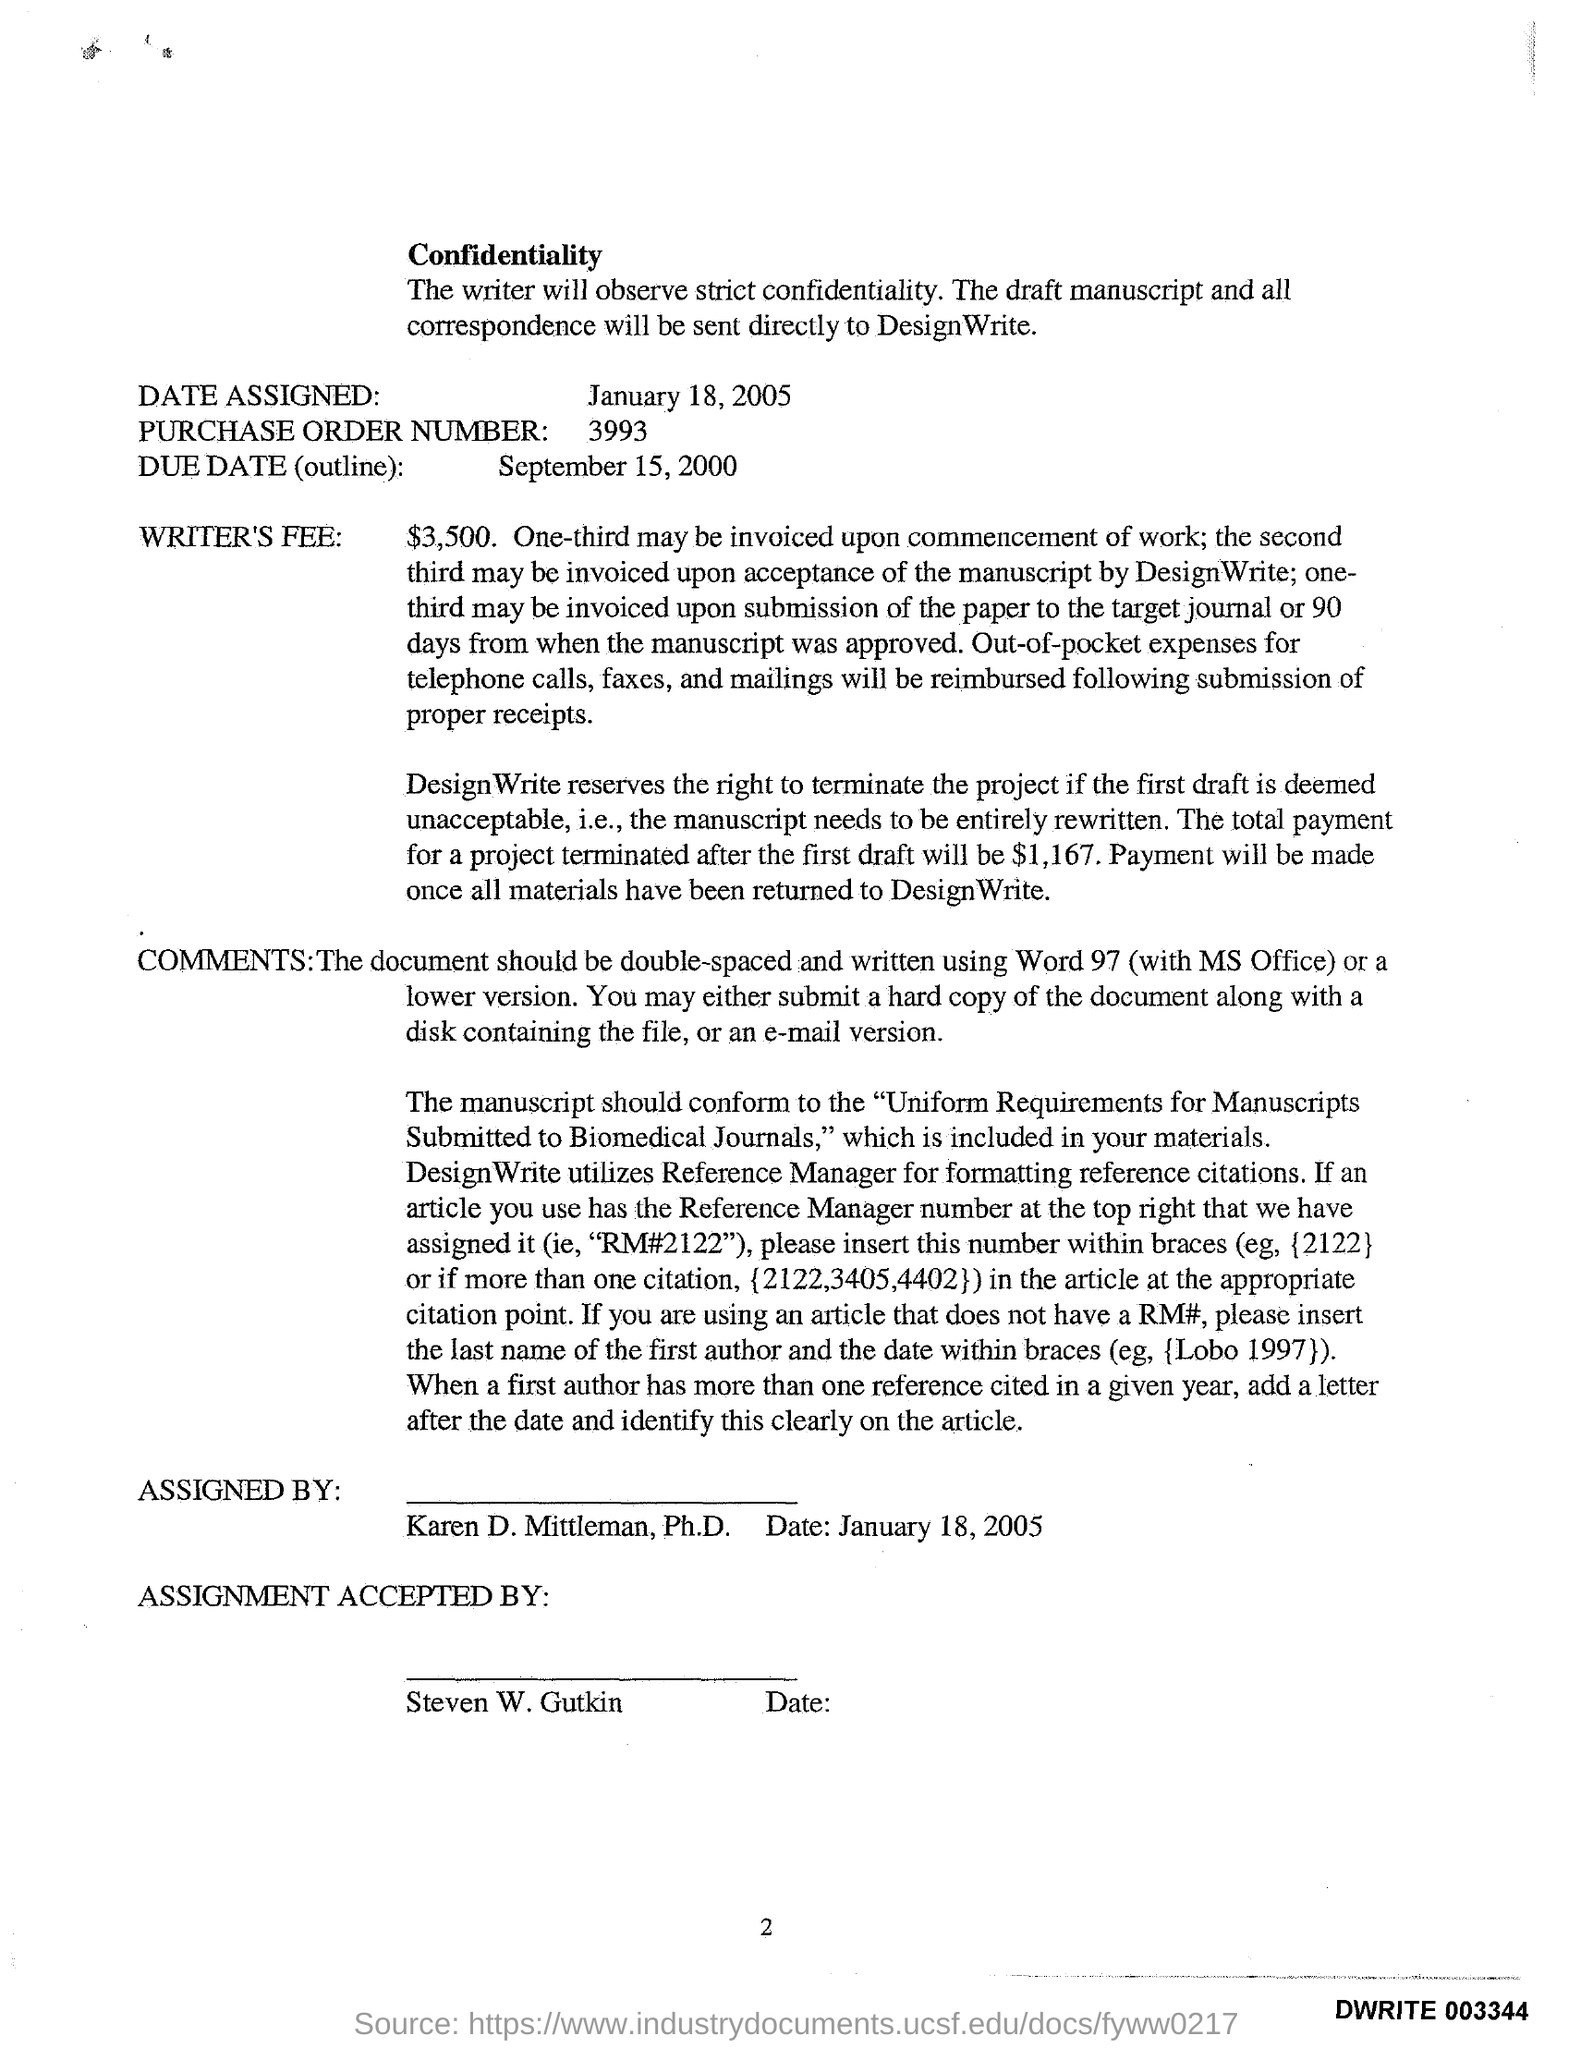What is the date assigned?
Provide a short and direct response. January 18, 2005. What is the purchase order number?
Your answer should be very brief. 3993. What is the due date(outline)?
Ensure brevity in your answer.  September 15, 2000. 